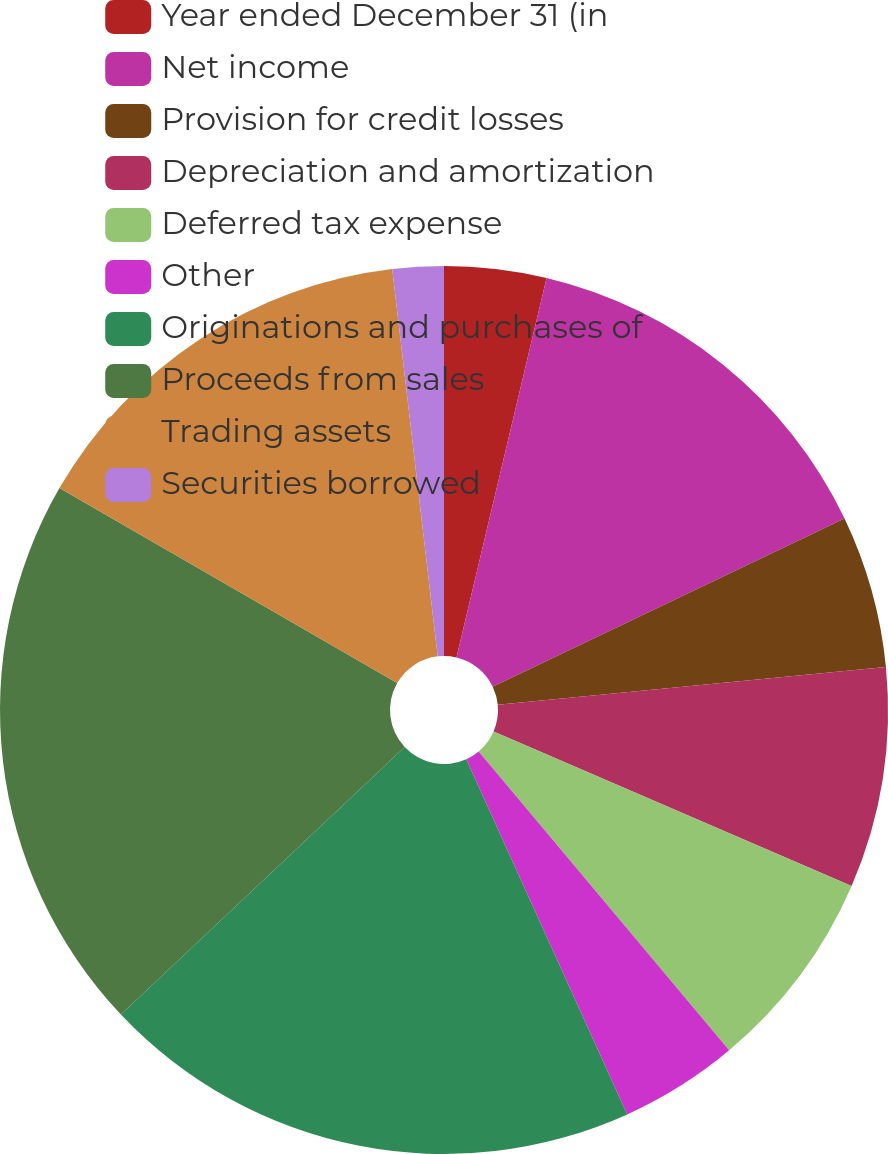Convert chart. <chart><loc_0><loc_0><loc_500><loc_500><pie_chart><fcel>Year ended December 31 (in<fcel>Net income<fcel>Provision for credit losses<fcel>Depreciation and amortization<fcel>Deferred tax expense<fcel>Other<fcel>Originations and purchases of<fcel>Proceeds from sales<fcel>Trading assets<fcel>Securities borrowed<nl><fcel>3.71%<fcel>14.19%<fcel>5.56%<fcel>8.03%<fcel>7.41%<fcel>4.33%<fcel>19.74%<fcel>20.36%<fcel>14.81%<fcel>1.86%<nl></chart> 